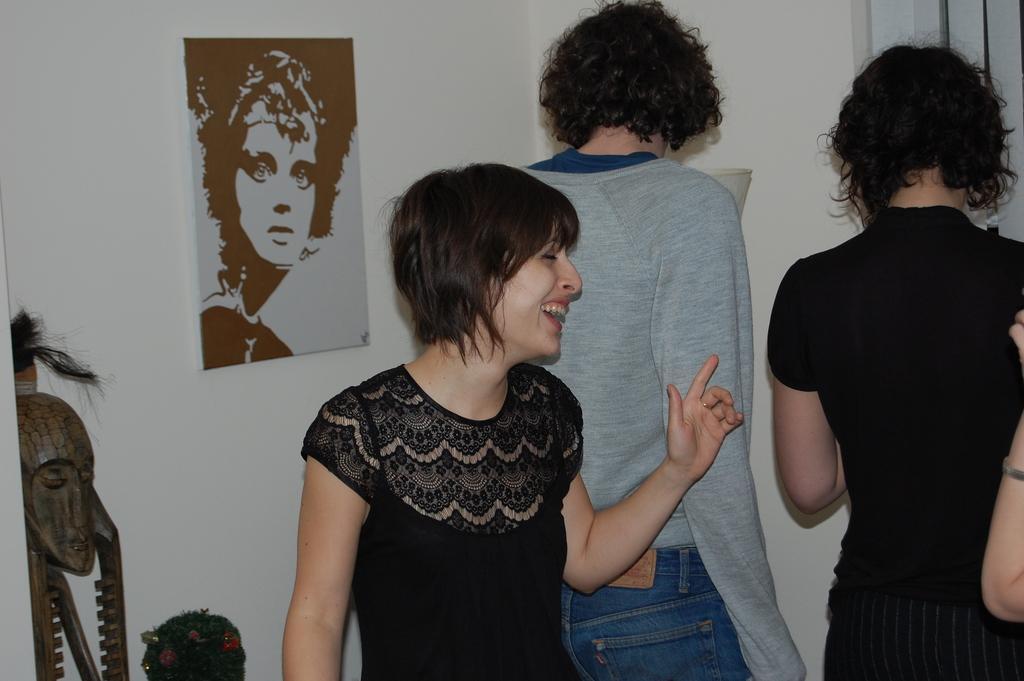Please provide a concise description of this image. In the picture we can see a woman standing and laughing and she is wearing a black dress and in the background, we can see two people are standing and facing the wall and on the wall we can see a painting of a person's face and besides to it we can see some sculptures. 